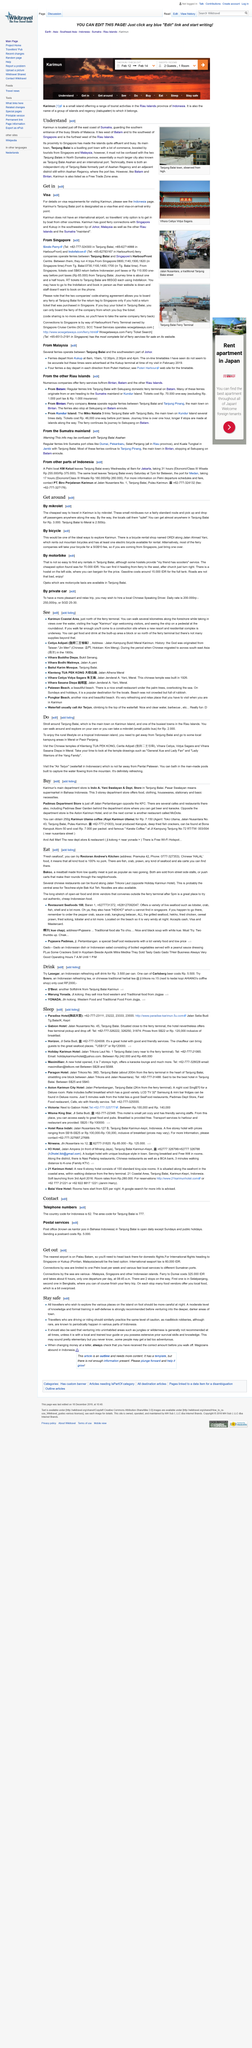Draw attention to some important aspects in this diagram. Karimun is located in Indonesia, which is a country known for its diverse culture and rich history. Ojeks, or motorcycle taxis, are a popular mode of transportation available in Tanjung Balai. The daily rate to hire a Chinese-speaking driver ranges from 200,000 rupiah to 250,000 rupiah, or approximately SGD 25-30. The most affordable method of travel in Karimun is by mikrolet, as it is the cheapest mode of transportation available. The cost of a Mikrolet is Rp. 2,000... 